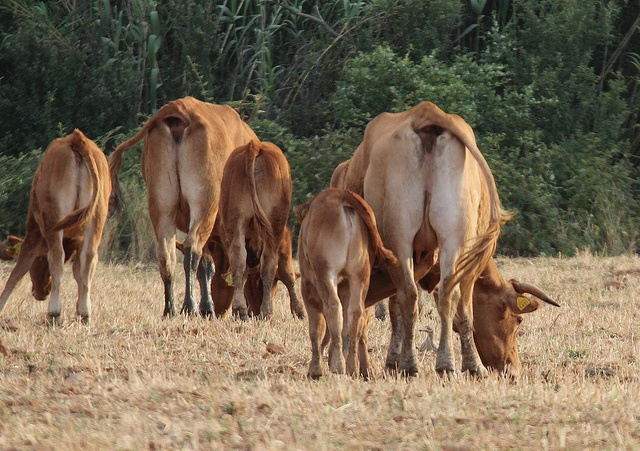Describe the objects in this image and their specific colors. I can see cow in black, gray, maroon, and tan tones, cow in black, gray, and maroon tones, cow in black, maroon, gray, and brown tones, cow in black, gray, brown, and maroon tones, and cow in black, maroon, brown, and gray tones in this image. 